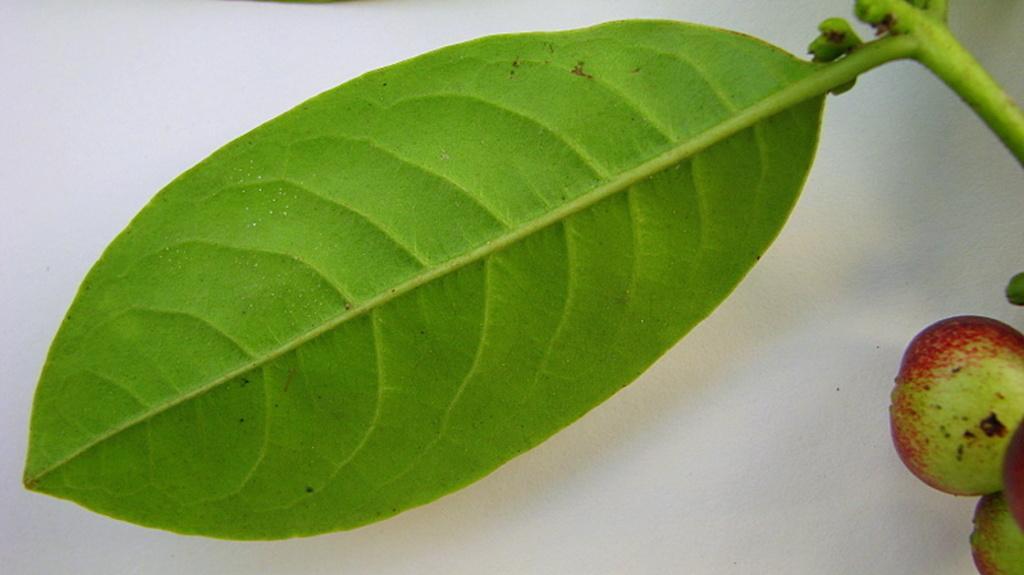Please provide a concise description of this image. In the foreground of this image, there is a leaf. On the right, there are fruits and the background image is blur. 